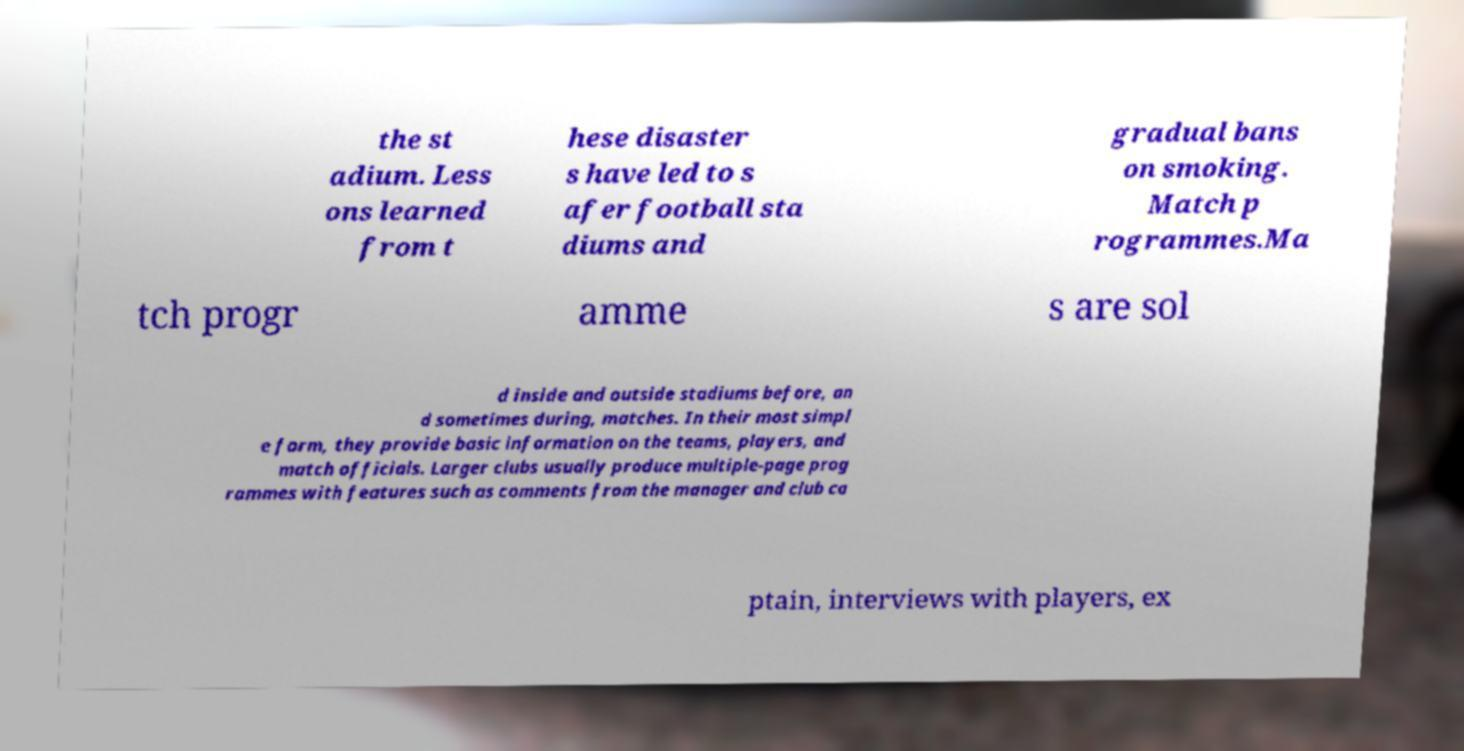Please identify and transcribe the text found in this image. the st adium. Less ons learned from t hese disaster s have led to s afer football sta diums and gradual bans on smoking. Match p rogrammes.Ma tch progr amme s are sol d inside and outside stadiums before, an d sometimes during, matches. In their most simpl e form, they provide basic information on the teams, players, and match officials. Larger clubs usually produce multiple-page prog rammes with features such as comments from the manager and club ca ptain, interviews with players, ex 